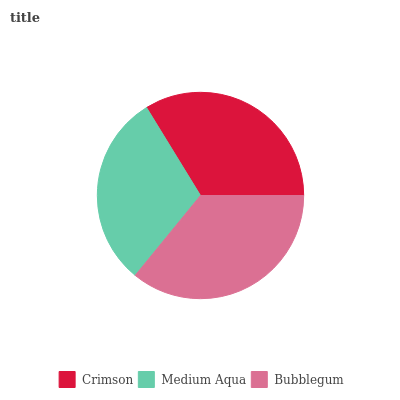Is Medium Aqua the minimum?
Answer yes or no. Yes. Is Bubblegum the maximum?
Answer yes or no. Yes. Is Bubblegum the minimum?
Answer yes or no. No. Is Medium Aqua the maximum?
Answer yes or no. No. Is Bubblegum greater than Medium Aqua?
Answer yes or no. Yes. Is Medium Aqua less than Bubblegum?
Answer yes or no. Yes. Is Medium Aqua greater than Bubblegum?
Answer yes or no. No. Is Bubblegum less than Medium Aqua?
Answer yes or no. No. Is Crimson the high median?
Answer yes or no. Yes. Is Crimson the low median?
Answer yes or no. Yes. Is Bubblegum the high median?
Answer yes or no. No. Is Bubblegum the low median?
Answer yes or no. No. 